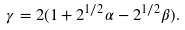Convert formula to latex. <formula><loc_0><loc_0><loc_500><loc_500>\gamma = 2 ( 1 + 2 ^ { 1 / 2 } \alpha - 2 ^ { 1 / 2 } \beta ) .</formula> 